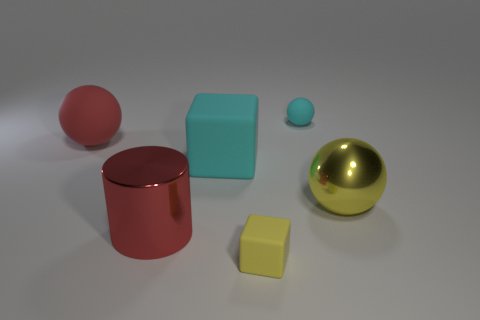What is the large cube made of?
Make the answer very short. Rubber. Are there any cyan matte spheres that have the same size as the cyan block?
Your answer should be compact. No. There is a cyan object that is the same size as the yellow metallic ball; what is its material?
Provide a short and direct response. Rubber. What number of cyan matte things are there?
Your response must be concise. 2. How big is the cyan block that is right of the large red rubber ball?
Keep it short and to the point. Large. Are there the same number of metallic cylinders that are to the right of the small block and large cyan matte objects?
Ensure brevity in your answer.  No. Are there any shiny things of the same shape as the red rubber object?
Provide a succinct answer. Yes. What shape is the matte thing that is right of the big red cylinder and to the left of the small yellow cube?
Offer a terse response. Cube. Is the large red ball made of the same material as the tiny object behind the big red cylinder?
Offer a terse response. Yes. There is a red shiny cylinder; are there any big red things in front of it?
Ensure brevity in your answer.  No. 